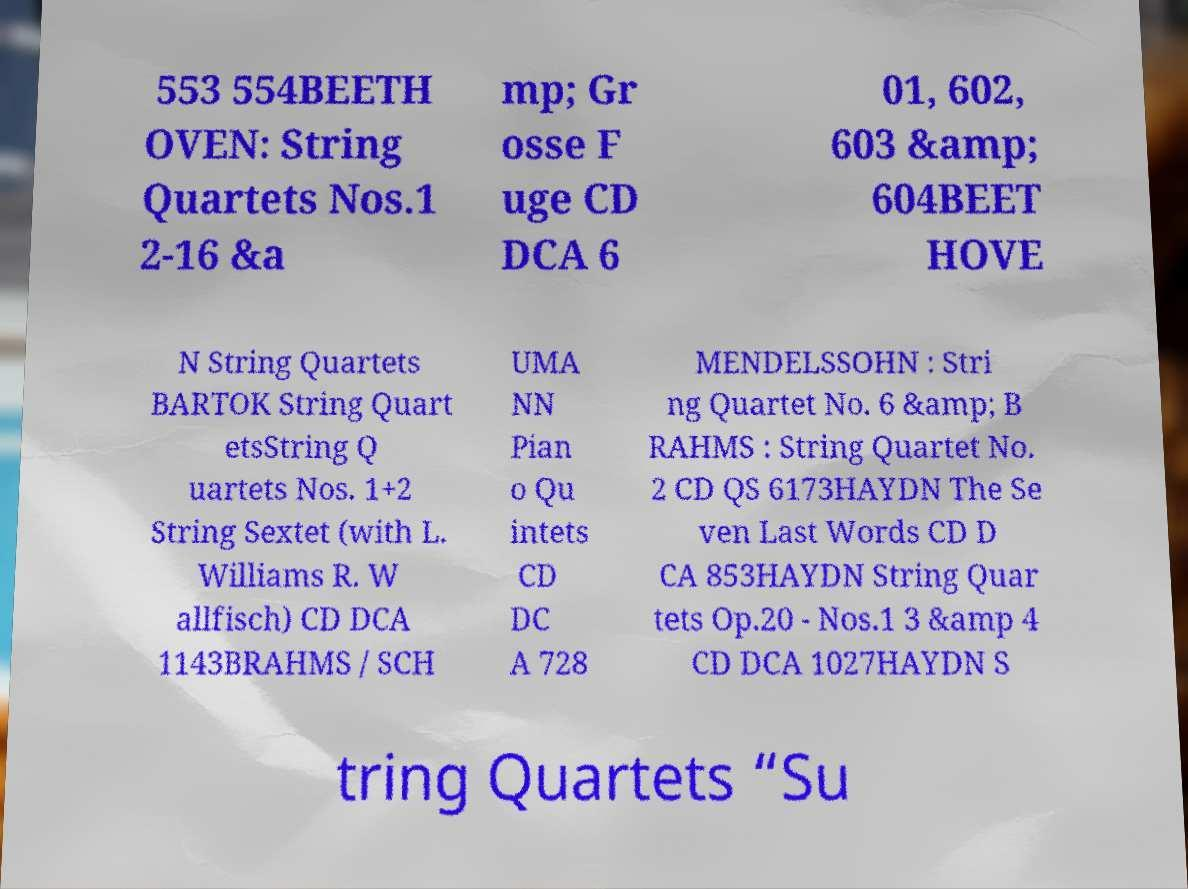Please read and relay the text visible in this image. What does it say? 553 554BEETH OVEN: String Quartets Nos.1 2-16 &a mp; Gr osse F uge CD DCA 6 01, 602, 603 &amp; 604BEET HOVE N String Quartets BARTOK String Quart etsString Q uartets Nos. 1+2 String Sextet (with L. Williams R. W allfisch) CD DCA 1143BRAHMS / SCH UMA NN Pian o Qu intets CD DC A 728 MENDELSSOHN : Stri ng Quartet No. 6 &amp; B RAHMS : String Quartet No. 2 CD QS 6173HAYDN The Se ven Last Words CD D CA 853HAYDN String Quar tets Op.20 - Nos.1 3 &amp 4 CD DCA 1027HAYDN S tring Quartets “Su 